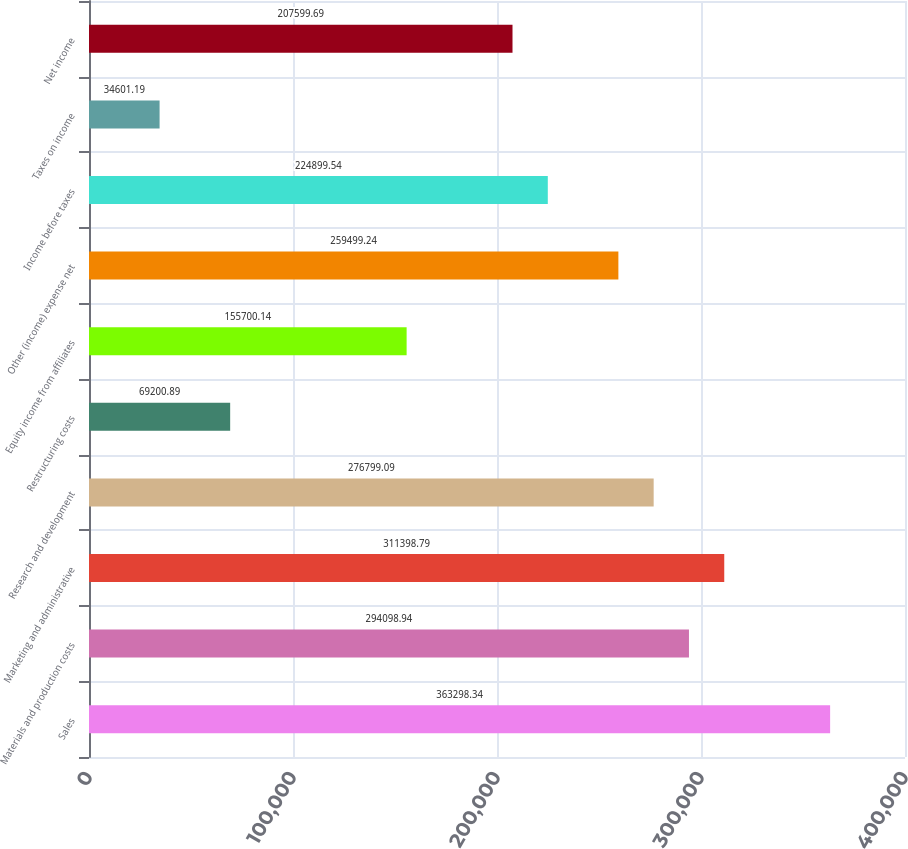Convert chart to OTSL. <chart><loc_0><loc_0><loc_500><loc_500><bar_chart><fcel>Sales<fcel>Materials and production costs<fcel>Marketing and administrative<fcel>Research and development<fcel>Restructuring costs<fcel>Equity income from affiliates<fcel>Other (income) expense net<fcel>Income before taxes<fcel>Taxes on income<fcel>Net income<nl><fcel>363298<fcel>294099<fcel>311399<fcel>276799<fcel>69200.9<fcel>155700<fcel>259499<fcel>224900<fcel>34601.2<fcel>207600<nl></chart> 